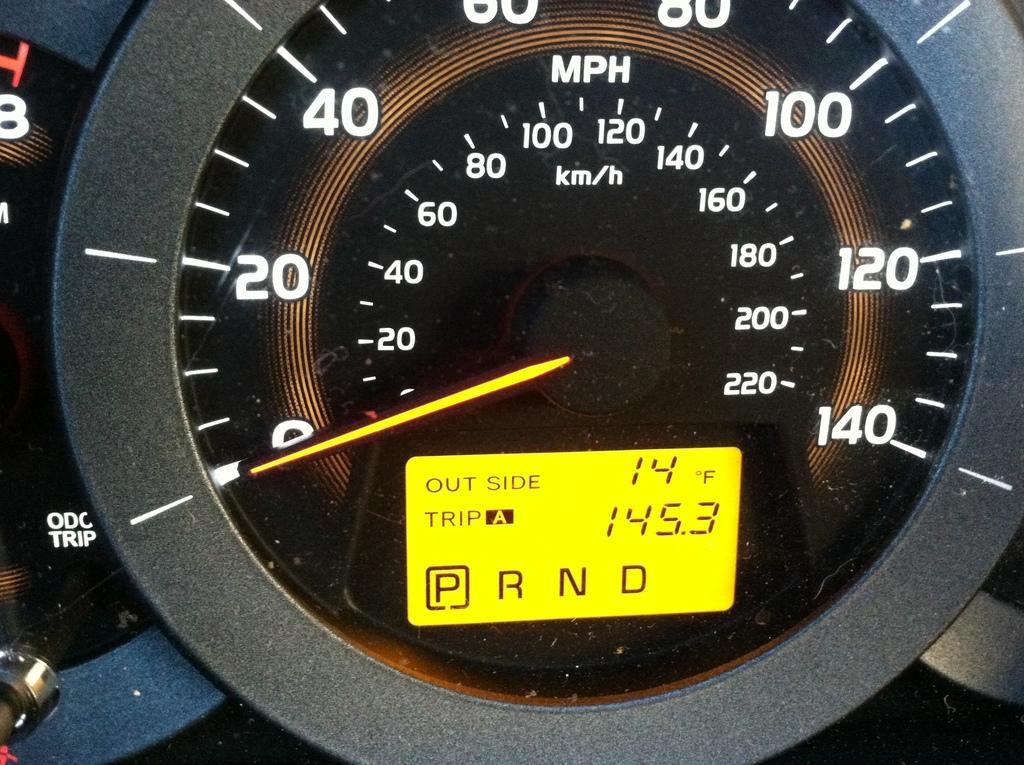Please provide a concise description of this image. In the foreground of this image, there is a speed meter in which there is a needle, few readings and units in it. 